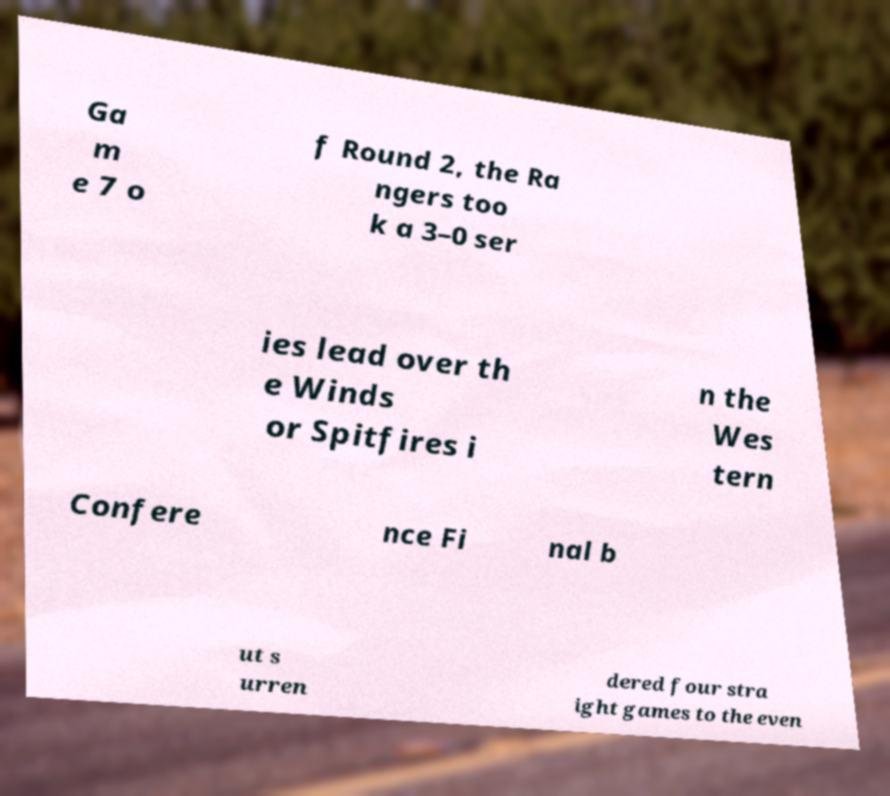Could you assist in decoding the text presented in this image and type it out clearly? Ga m e 7 o f Round 2, the Ra ngers too k a 3–0 ser ies lead over th e Winds or Spitfires i n the Wes tern Confere nce Fi nal b ut s urren dered four stra ight games to the even 